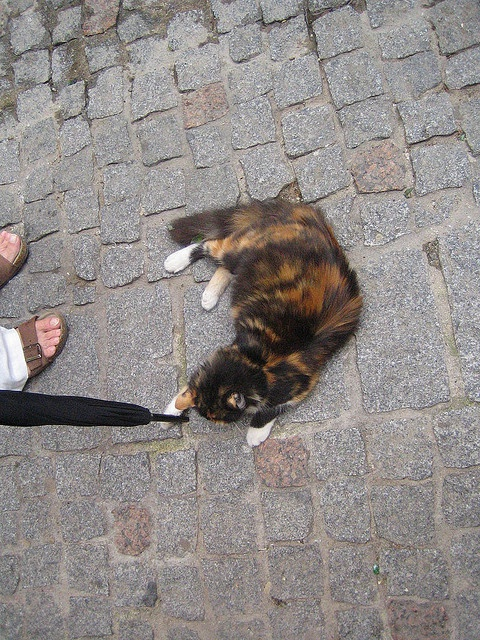Describe the objects in this image and their specific colors. I can see cat in gray, black, and maroon tones, people in gray, lightgray, and lightpink tones, and umbrella in gray, black, and darkgray tones in this image. 